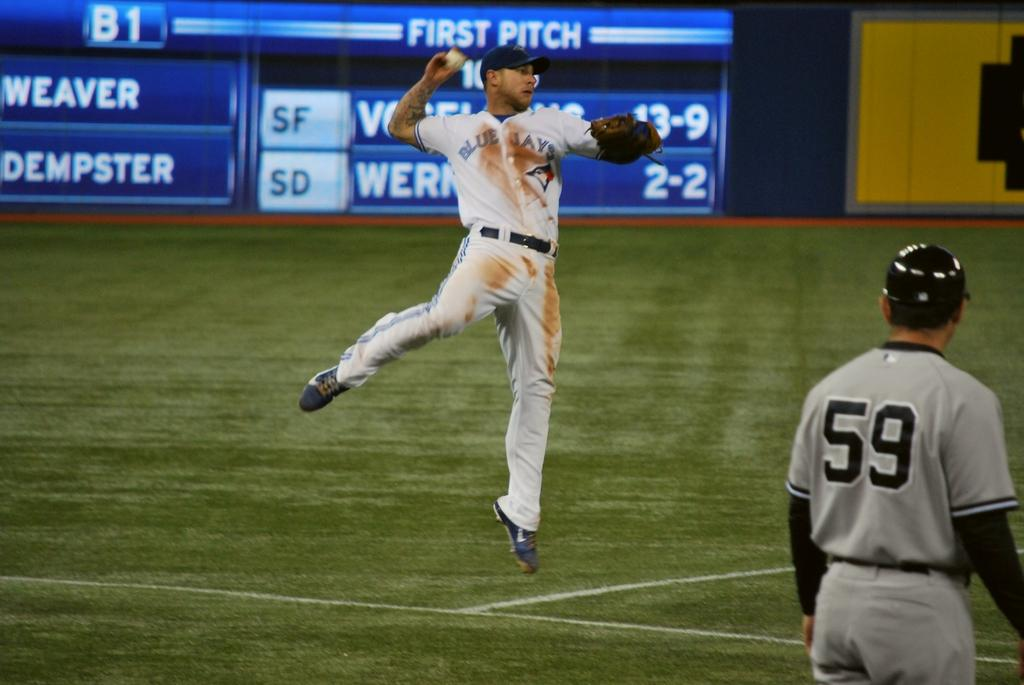<image>
Render a clear and concise summary of the photo. a player that has the number 59 on their jersey 